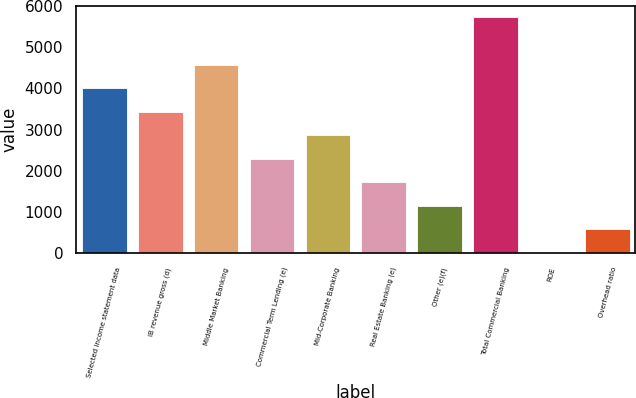Convert chart to OTSL. <chart><loc_0><loc_0><loc_500><loc_500><bar_chart><fcel>Selected income statement data<fcel>IB revenue gross (d)<fcel>Middle Market Banking<fcel>Commercial Term Lending (e)<fcel>Mid-Corporate Banking<fcel>Real Estate Banking (e)<fcel>Other (e)(f)<fcel>Total Commercial Banking<fcel>ROE<fcel>Overhead ratio<nl><fcel>4008.8<fcel>3438.4<fcel>4579.2<fcel>2297.6<fcel>2868<fcel>1727.2<fcel>1156.8<fcel>5720<fcel>16<fcel>586.4<nl></chart> 